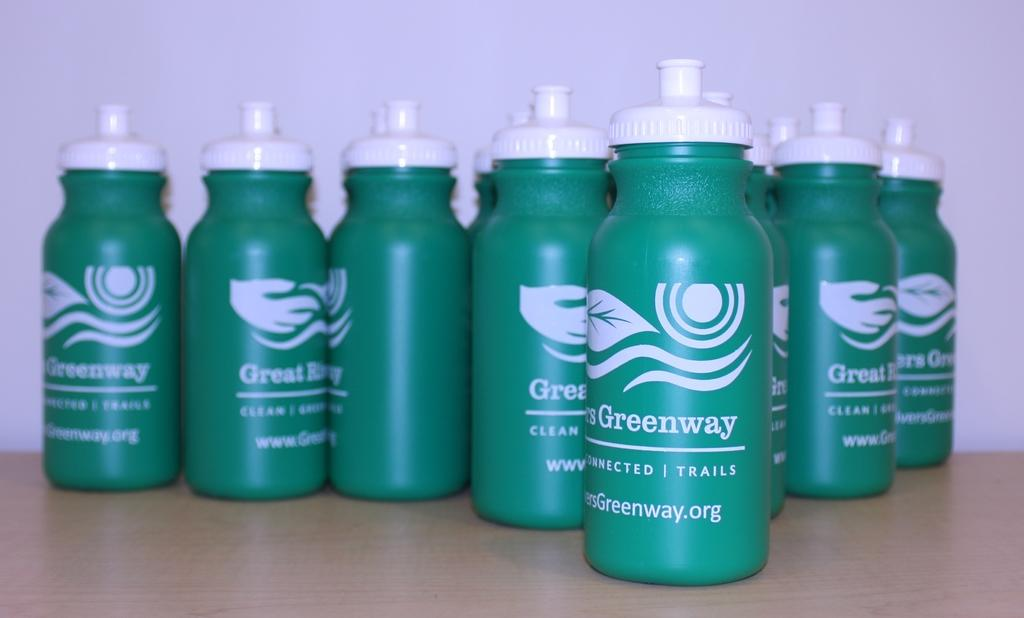<image>
Present a compact description of the photo's key features. Greenway Connected Trails thermos bottles with a green background. 